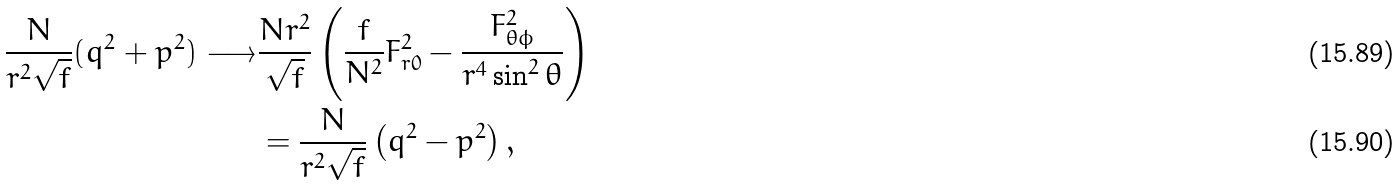<formula> <loc_0><loc_0><loc_500><loc_500>\frac { N } { r ^ { 2 } \sqrt { f } } ( q ^ { 2 } + p ^ { 2 } ) \longrightarrow & \frac { N r ^ { 2 } } { \sqrt { f } } \left ( \frac { f } { N ^ { 2 } } F _ { r 0 } ^ { 2 } - \frac { F _ { \theta \phi } ^ { 2 } } { r ^ { 4 } \sin ^ { 2 } \theta } \right ) \\ & = \frac { N } { r ^ { 2 } \sqrt { f } } \left ( q ^ { 2 } - p ^ { 2 } \right ) ,</formula> 